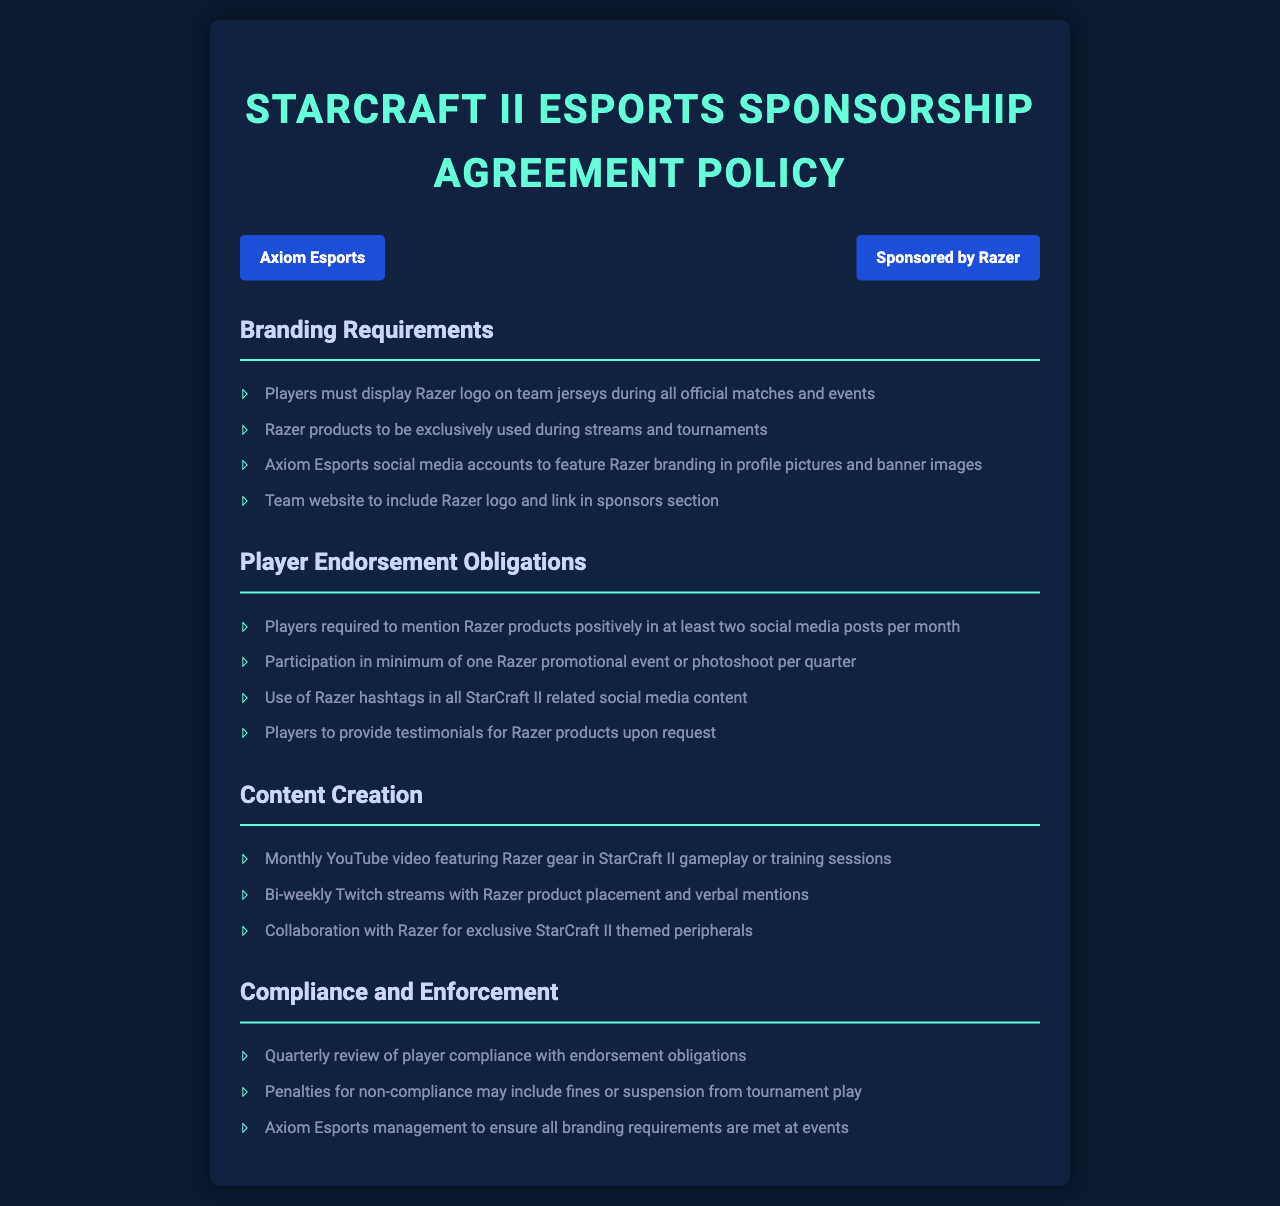what logo must players display during matches? Players are required to display the Razer logo on their team jerseys during all official matches and events.
Answer: Razer logo how often must players post about Razer products on social media? Players are required to mention Razer products positively in at least two social media posts per month.
Answer: Two posts per month what is the minimum number of Razer promotional events a player must participate in per quarter? Players must participate in a minimum of one Razer promotional event or photoshoot per quarter.
Answer: One event per quarter what must Axiom Esports social media accounts feature? Axiom Esports social media accounts must feature Razer branding in profile pictures and banner images.
Answer: Razer branding what is the consequence for non-compliance with endorsement obligations? Penalties for non-compliance may include fines or suspension from tournament play.
Answer: Fines or suspension how frequently should players create YouTube content featuring Razer gear? Players are required to create a monthly YouTube video featuring Razer gear in StarCraft II gameplay or training sessions.
Answer: Monthly how often must branding requirements be reviewed? There will be a quarterly review of player compliance with endorsement obligations.
Answer: Quarterly what color is the background of the document? The background color of the document is #0a192f.
Answer: #0a192f 